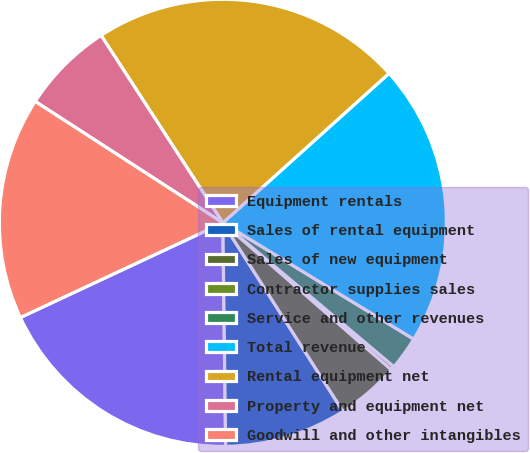Convert chart to OTSL. <chart><loc_0><loc_0><loc_500><loc_500><pie_chart><fcel>Equipment rentals<fcel>Sales of rental equipment<fcel>Sales of new equipment<fcel>Contractor supplies sales<fcel>Service and other revenues<fcel>Total revenue<fcel>Rental equipment net<fcel>Property and equipment net<fcel>Goodwill and other intangibles<nl><fcel>18.24%<fcel>8.83%<fcel>4.56%<fcel>0.28%<fcel>2.42%<fcel>20.37%<fcel>22.51%<fcel>6.69%<fcel>16.1%<nl></chart> 